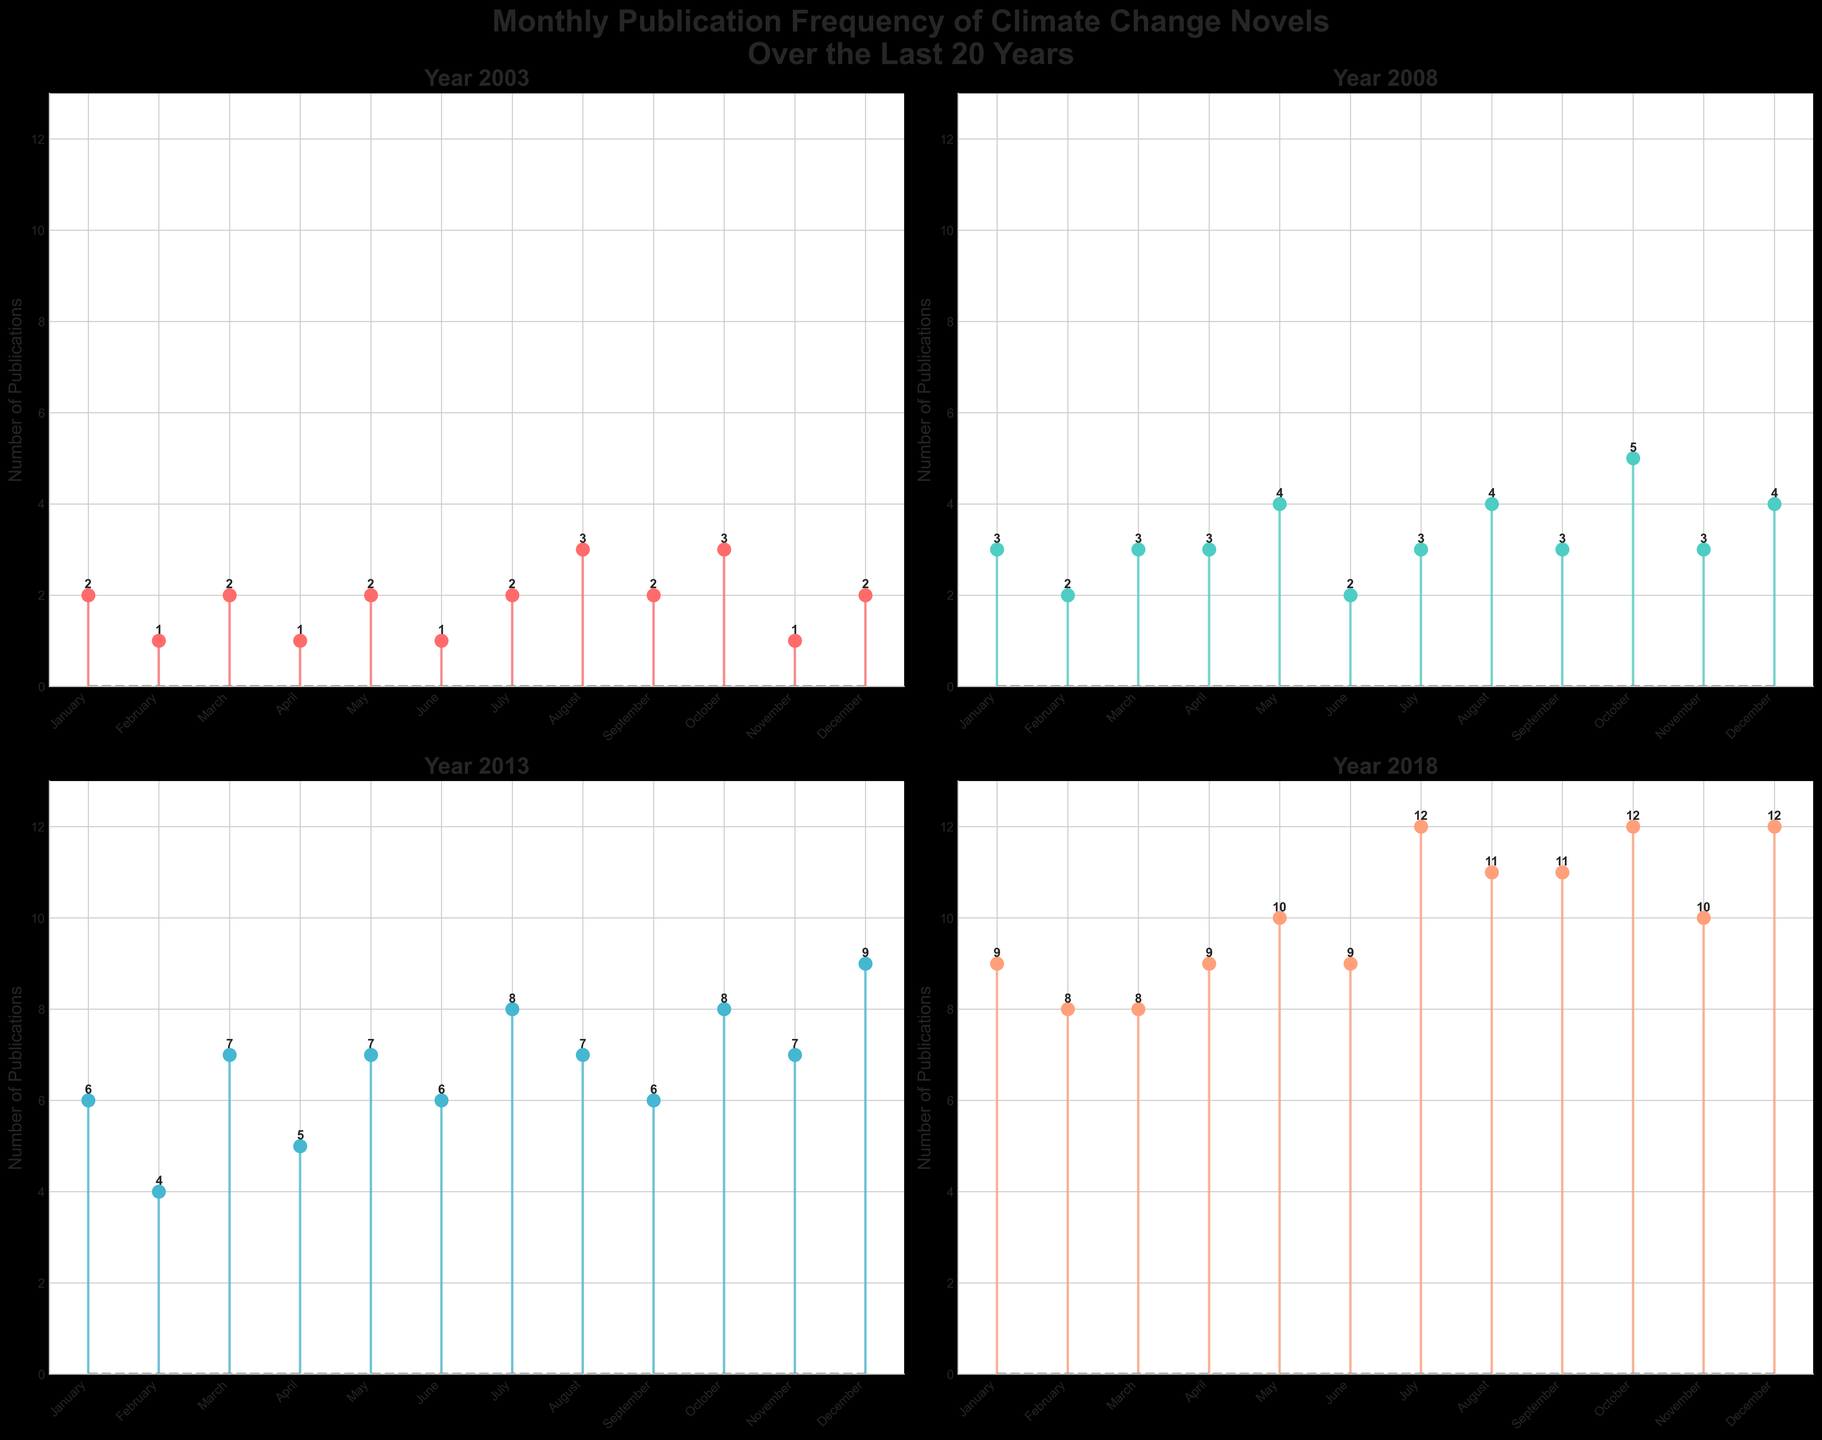What is the overall trend observed in the number of publications from 2003 to 2018? The overall trend shows an increase in the number of publications related to climate change novels over the years. 2003 had relatively fewer publications each month, 2008 saw a moderate increase, 2013 had a significant rise, and 2018 showed the highest number of publications monthly.
Answer: Increasing trend Which month in 2018 had the highest number of publications? By looking at the 2018 plot, December had the highest number of publications with 12.
Answer: December Compare the number of publications in January over the four years shown. Which year had the most publications in January? In the plots for each year, January had the following number of publications: 2003 (2), 2008 (3), 2013 (6), and 2018 (9). Thus, 2018 had the most publications in January.
Answer: 2018 What's the difference in the number of publications between the year with the most publications in November and the year with the least publications in November? In November, the numbers are 2003 (1), 2008 (3), 2013 (7), and 2018 (10). The difference between the most (2018) and the least (2003) is 10 - 1.
Answer: 9 Which year observed a sudden expansion from a relatively moderate to a significantly higher number of publications? Comparing the number of publications from year to year, 2013 saw a significant expansion in the publication numbers compared to 2008.
Answer: 2013 What is the average number of publications per month in 2003? Adding the publications for each month in 2003 (2 + 1 + 2 + 1 + 2 + 1 + 2 + 3 + 2 + 3 + 1 + 2) gives a total of 22. Dividing this by 12 (the number of months) results in 22/12.
Answer: 1.83 During which year did July and October have the same number of publications? In 2008, both July and October had 3 publications each.
Answer: 2008 Which year had the most consistent number of publications throughout the months? Observing the monthly values, 2018 shows the most consistency with numbers mostly ranging between 8 and 12.
Answer: 2018 How does the number of publications in October compare across the years? October had the following number of publications: 2003 (3), 2008 (5), 2013 (8), and 2018 (12). The number steadily increases each year.
Answer: Steady increase In 2013, what is the total number of publications from March through June? Adding the values from March to June in 2013 (7 + 5 + 7 + 6) yields 25 total publications.
Answer: 25 